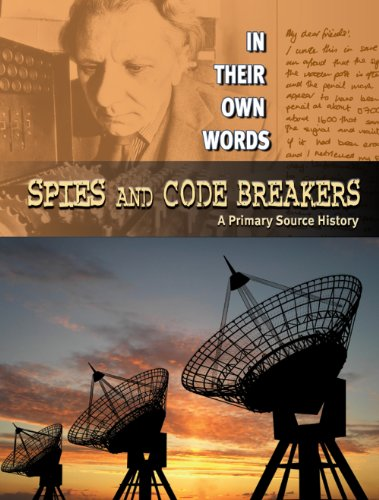What is the title of this book? The title of this engaging book is 'Spies and Code Breakers: A Primary Source History', an intriguing exploration in their own words. 